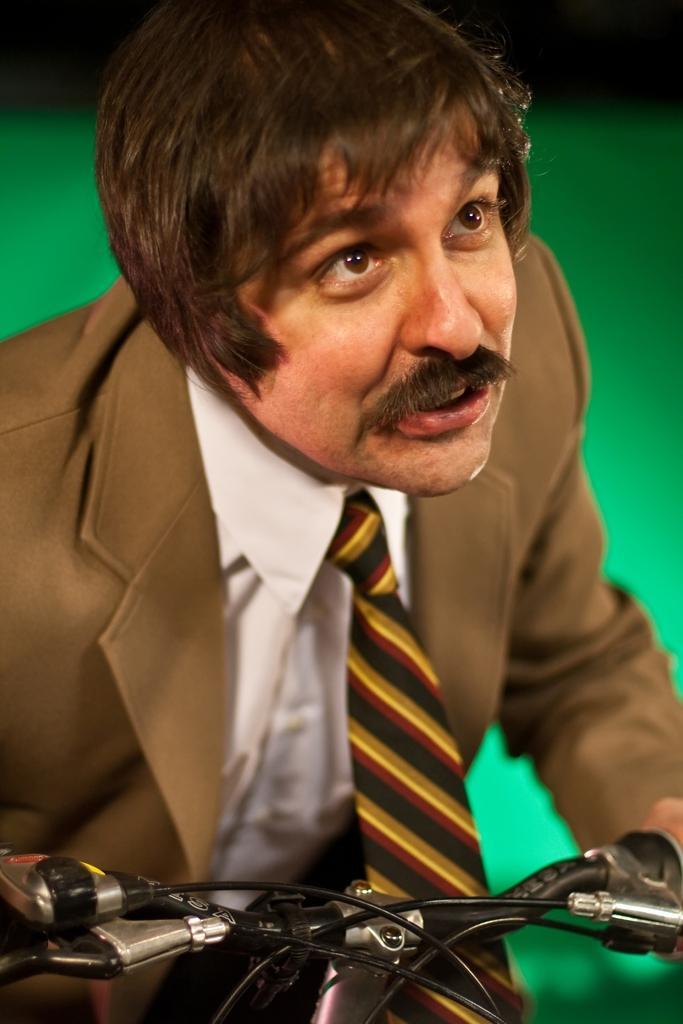How would you summarize this image in a sentence or two? This picture shows a man wearing a suit on a bicycle, looking at someone. 